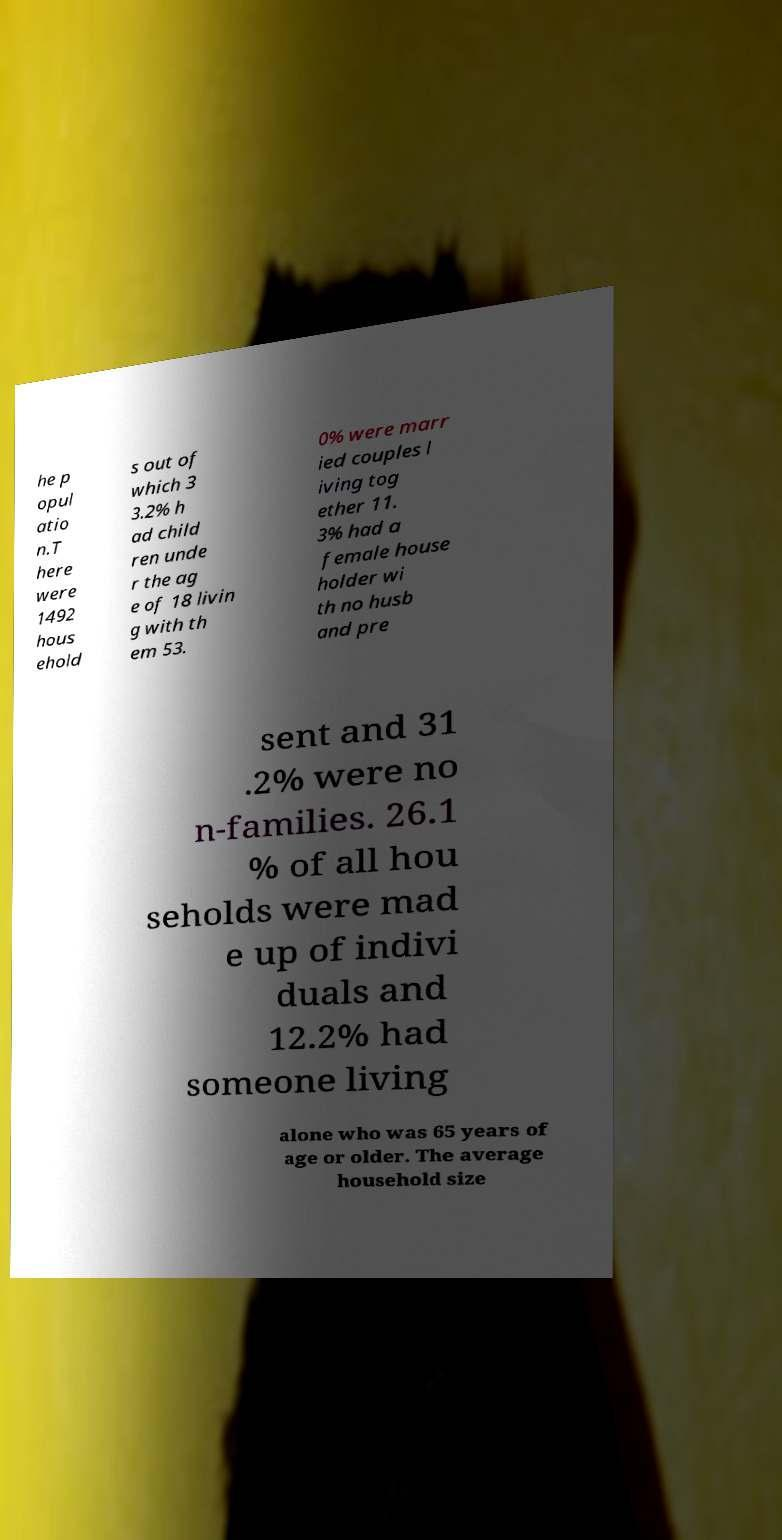Can you accurately transcribe the text from the provided image for me? he p opul atio n.T here were 1492 hous ehold s out of which 3 3.2% h ad child ren unde r the ag e of 18 livin g with th em 53. 0% were marr ied couples l iving tog ether 11. 3% had a female house holder wi th no husb and pre sent and 31 .2% were no n-families. 26.1 % of all hou seholds were mad e up of indivi duals and 12.2% had someone living alone who was 65 years of age or older. The average household size 